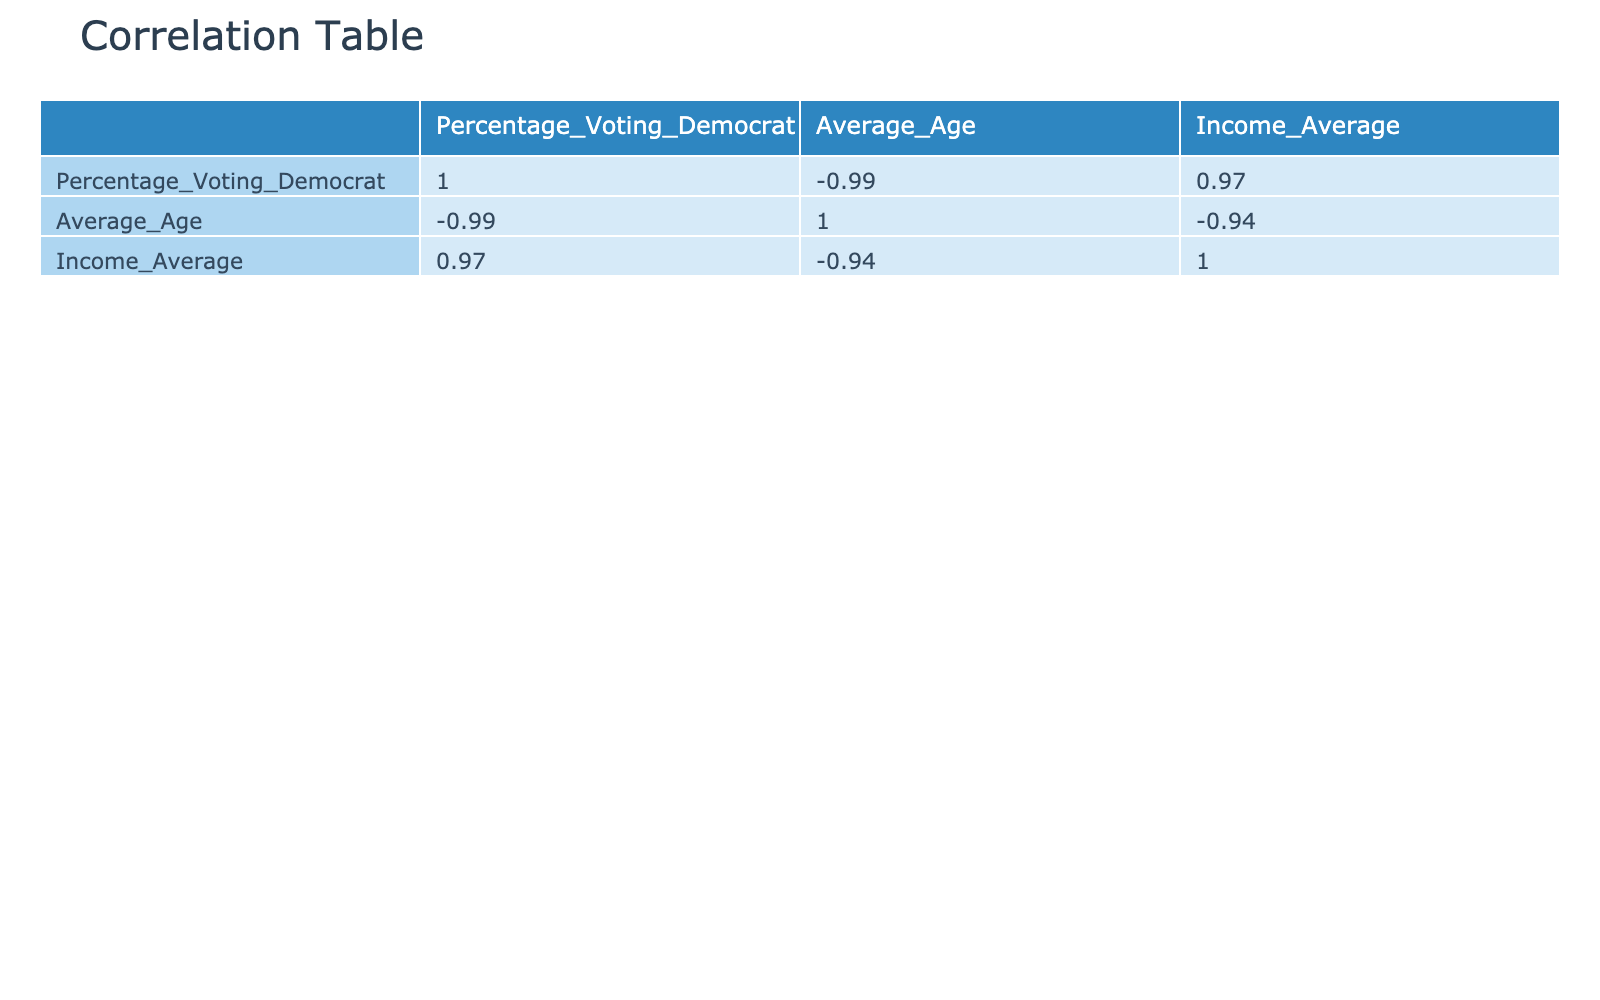What is the percentage of voting Democrat among individuals with a Bachelor's Degree? The table shows that those with a Bachelor's Degree have a percentage of voting Democrat equal to 70.
Answer: 70 Which education level has the highest percentage of voting Democrat? By examining the table, it is clear that the education level with the highest percentage of voting Democrat is a Graduate Degree with 80%.
Answer: 80% What is the average age of individuals with Less than High School education? The table indicates that the average age for individuals with Less than High School education is 50.
Answer: 50 Is it true that a higher education level corresponds to a higher average income? Evaluating the data, we can see that as the education level increases, the average income also increases: High School - 35000, Some College - 42000, Bachelor's Degree - 60000, Graduate Degree - 80000. Thus, the statement is true.
Answer: Yes What is the total average income of individuals with some college or less? The average incomes for individuals with different education levels are as follows: Less than High School - 25000, High School - 35000, Some College - 42000. To find the total income, we add these: 25000 + 35000 + 42000 = 102000. The average is then 102000 / 3 = 34000.
Answer: 34000 Which education level has the lowest percentage of voting Democrat? Looking at the table, the education level with the lowest percentage of voting Democrat is Less than High School, which is 30%.
Answer: 30 What is the difference in average age between those with a Graduate Degree and those with a High School education? The average age for graduates with a Graduate Degree is 28, while the average age for those with a High School education is 42. The difference is calculated as 42 - 28 = 14.
Answer: 14 Is the percentage of voting Democrat lowest among individuals with an Associate Degree compared to those with a Bachelor’s Degree? According to the table, the percentage of voting Democrat for Associate Degree holders is 60%, while for Bachelor’s Degree holders, it is 70%. Therefore, the statement is false as Associates have a higher percentage.
Answer: No What is the average voting percentage for education levels below a Bachelor's Degree? The education levels below a Bachelor's Degree are High School (45), Some College (55), and Associate Degree (60). The total is 45 + 55 + 60 = 160. To find the average: 160 / 3 = 53.33.
Answer: 53.33 